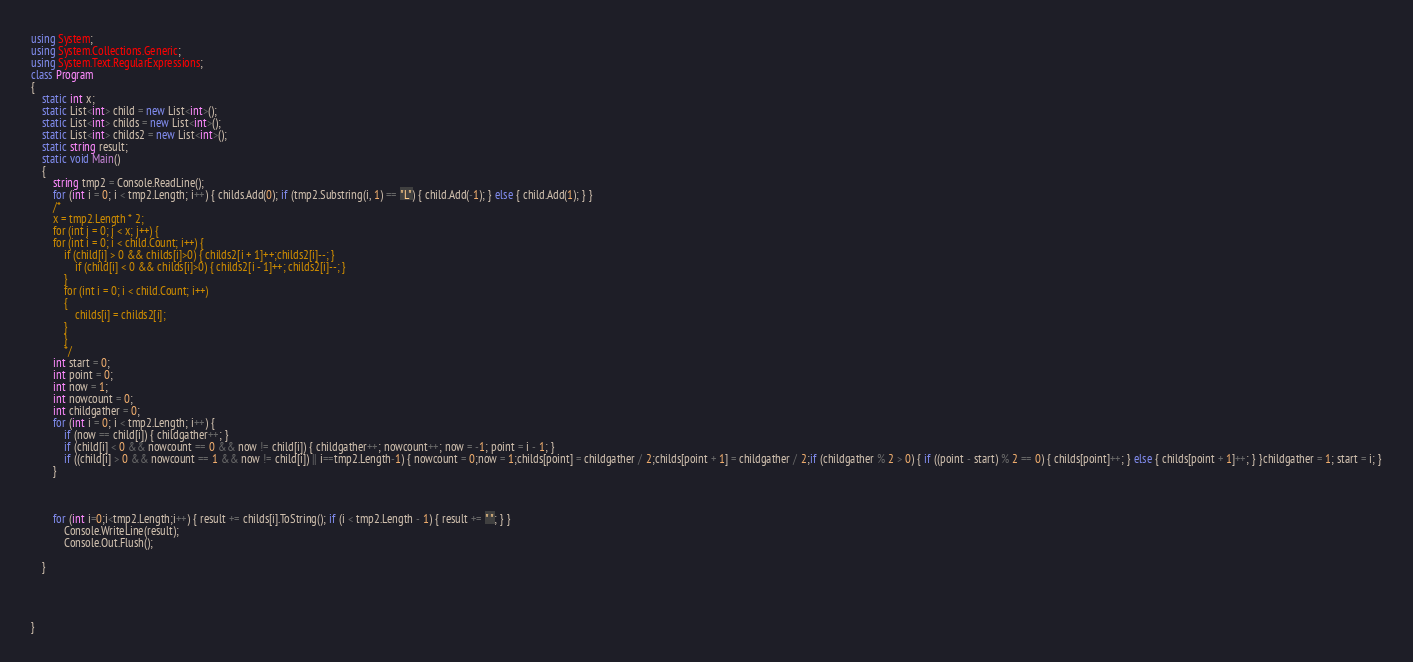Convert code to text. <code><loc_0><loc_0><loc_500><loc_500><_C#_>using System;
using System.Collections.Generic;
using System.Text.RegularExpressions;
class Program
{
    static int x;
    static List<int> child = new List<int>();
    static List<int> childs = new List<int>();
    static List<int> childs2 = new List<int>();
    static string result;
    static void Main()
    {
        string tmp2 = Console.ReadLine();
        for (int i = 0; i < tmp2.Length; i++) { childs.Add(0); if (tmp2.Substring(i, 1) == "L") { child.Add(-1); } else { child.Add(1); } }
        /*
        x = tmp2.Length * 2;
        for (int j = 0; j < x; j++) {
        for (int i = 0; i < child.Count; i++) {
            if (child[i] > 0 && childs[i]>0) { childs2[i + 1]++;childs2[i]--; }
                if (child[i] < 0 && childs[i]>0) { childs2[i - 1]++; childs2[i]--; }
            }
            for (int i = 0; i < child.Count; i++)
            {
                childs[i] = childs2[i];
            }
            }
            */
        int start = 0;
        int point = 0;
        int now = 1;
        int nowcount = 0;
        int childgather = 0;
        for (int i = 0; i < tmp2.Length; i++) {
            if (now == child[i]) { childgather++; }
            if (child[i] < 0 && nowcount == 0 && now != child[i]) { childgather++; nowcount++; now = -1; point = i - 1; }
            if ((child[i] > 0 && nowcount == 1 && now != child[i]) || i==tmp2.Length-1) { nowcount = 0;now = 1;childs[point] = childgather / 2;childs[point + 1] = childgather / 2;if (childgather % 2 > 0) { if ((point - start) % 2 == 0) { childs[point]++; } else { childs[point + 1]++; } }childgather = 1; start = i; }
        }



        for (int i=0;i<tmp2.Length;i++) { result += childs[i].ToString(); if (i < tmp2.Length - 1) { result += " "; } }
            Console.WriteLine(result);
            Console.Out.Flush();
        
    }

 


}</code> 